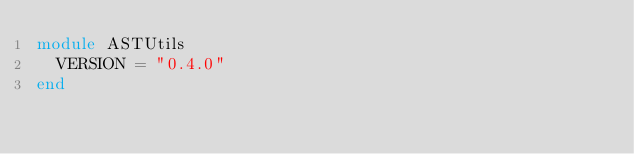Convert code to text. <code><loc_0><loc_0><loc_500><loc_500><_Ruby_>module ASTUtils
  VERSION = "0.4.0"
end
</code> 